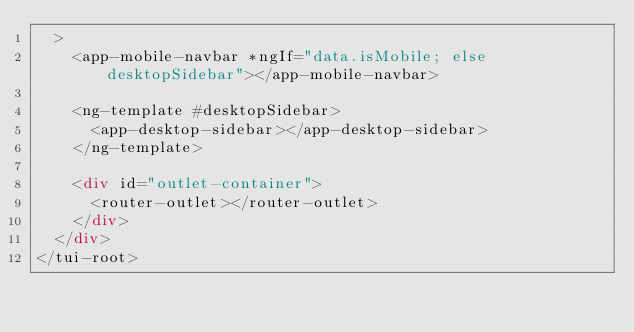<code> <loc_0><loc_0><loc_500><loc_500><_HTML_>  >
    <app-mobile-navbar *ngIf="data.isMobile; else desktopSidebar"></app-mobile-navbar>

    <ng-template #desktopSidebar>
      <app-desktop-sidebar></app-desktop-sidebar>
    </ng-template>

    <div id="outlet-container">
      <router-outlet></router-outlet>
    </div>
  </div>
</tui-root>
</code> 